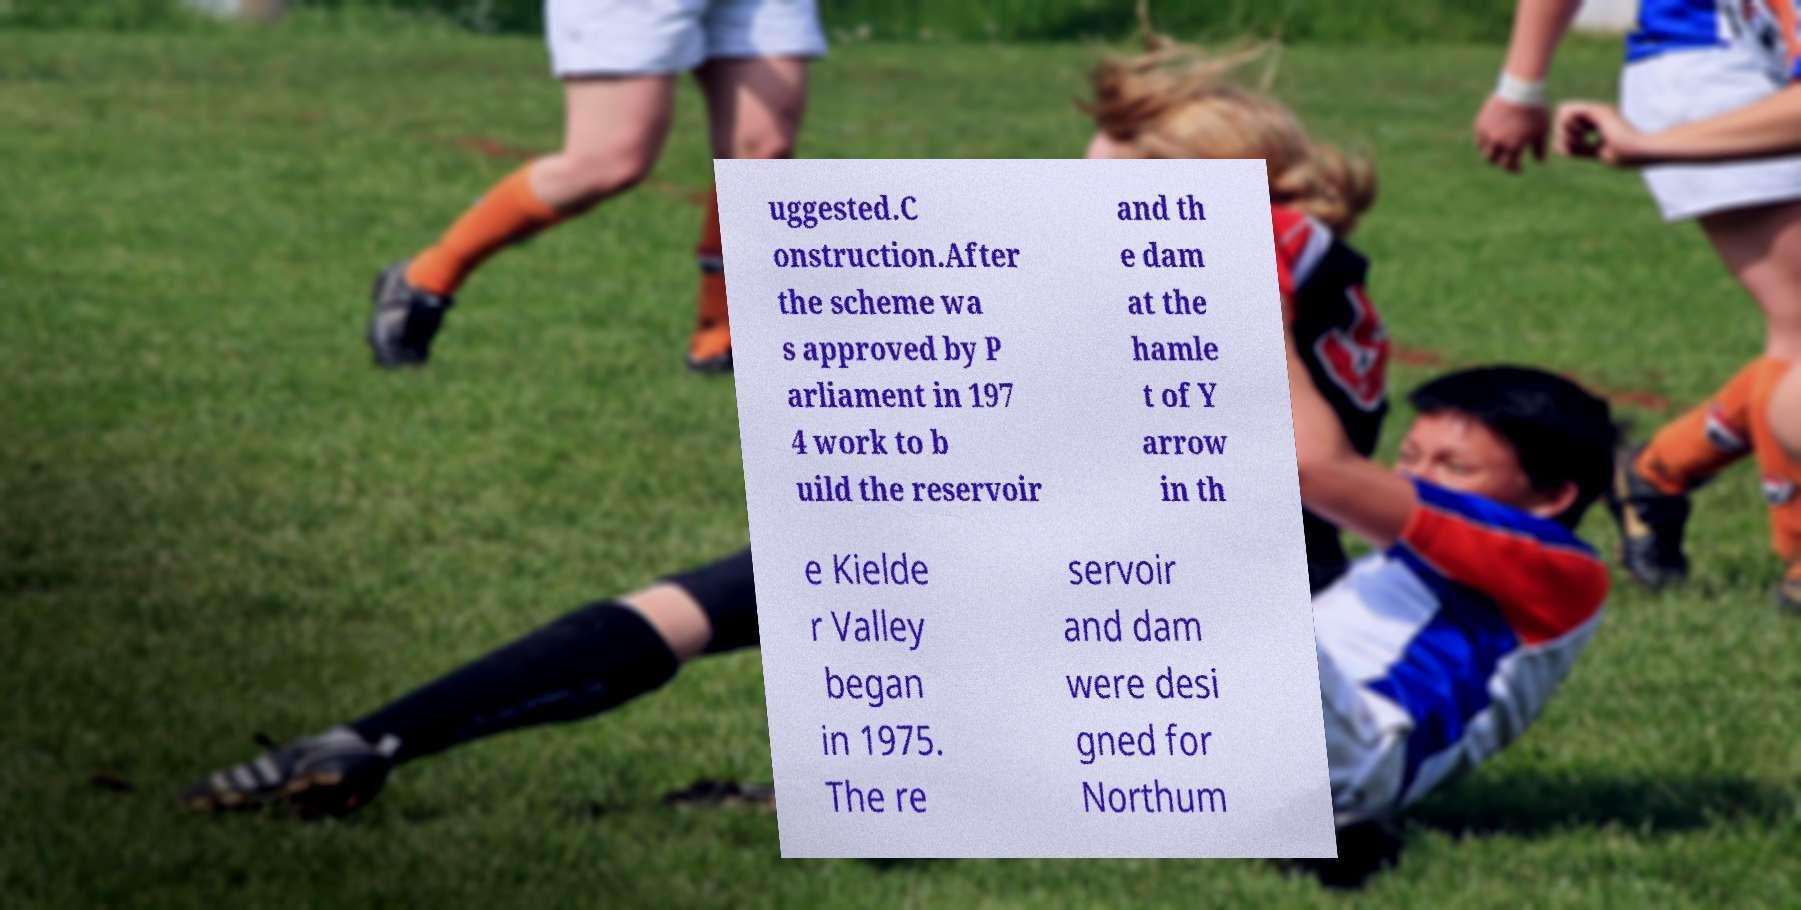I need the written content from this picture converted into text. Can you do that? uggested.C onstruction.After the scheme wa s approved by P arliament in 197 4 work to b uild the reservoir and th e dam at the hamle t of Y arrow in th e Kielde r Valley began in 1975. The re servoir and dam were desi gned for Northum 